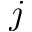Convert formula to latex. <formula><loc_0><loc_0><loc_500><loc_500>j</formula> 